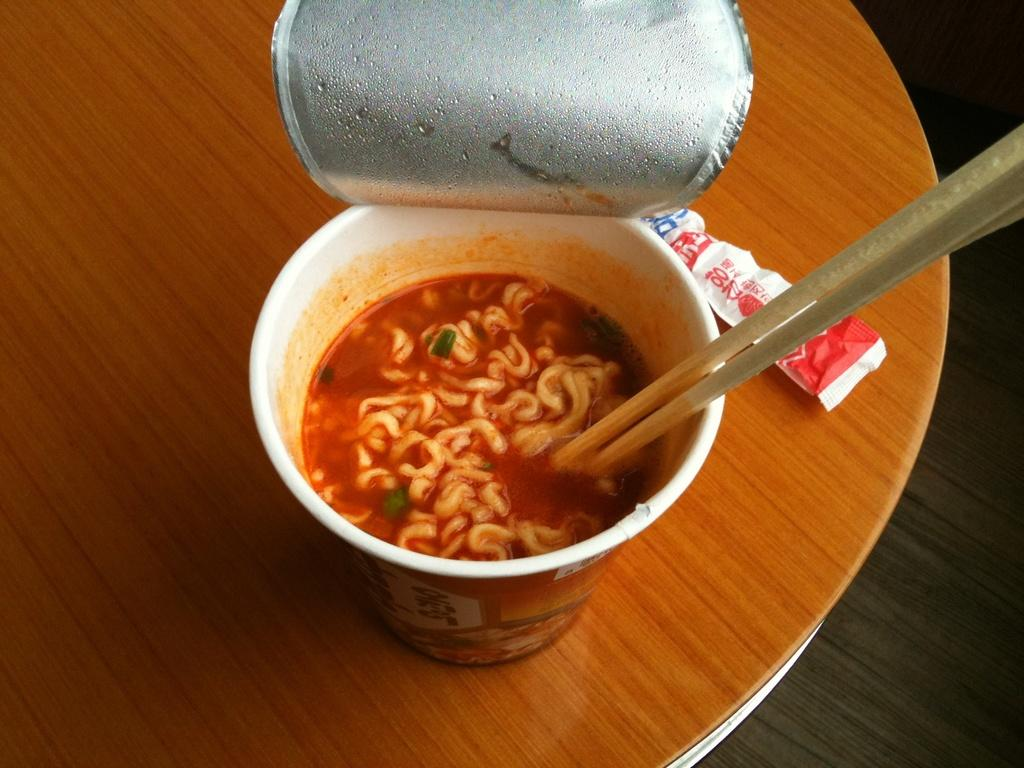What is the food item on the table in the image? The provided facts do not specify the type of food item on the table. What utensils are present on the table? Chopsticks are present on the table. What type of vest is being worn by the plants in the image? There are no plants or vests present in the image. 